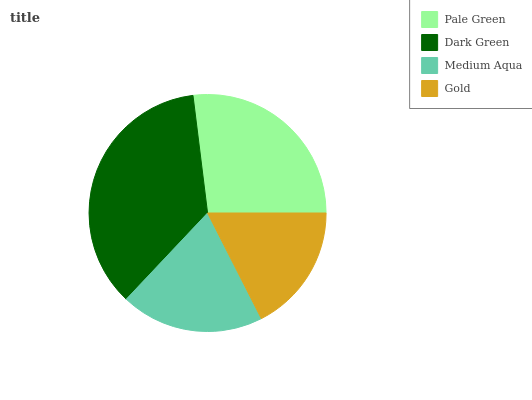Is Gold the minimum?
Answer yes or no. Yes. Is Dark Green the maximum?
Answer yes or no. Yes. Is Medium Aqua the minimum?
Answer yes or no. No. Is Medium Aqua the maximum?
Answer yes or no. No. Is Dark Green greater than Medium Aqua?
Answer yes or no. Yes. Is Medium Aqua less than Dark Green?
Answer yes or no. Yes. Is Medium Aqua greater than Dark Green?
Answer yes or no. No. Is Dark Green less than Medium Aqua?
Answer yes or no. No. Is Pale Green the high median?
Answer yes or no. Yes. Is Medium Aqua the low median?
Answer yes or no. Yes. Is Medium Aqua the high median?
Answer yes or no. No. Is Gold the low median?
Answer yes or no. No. 